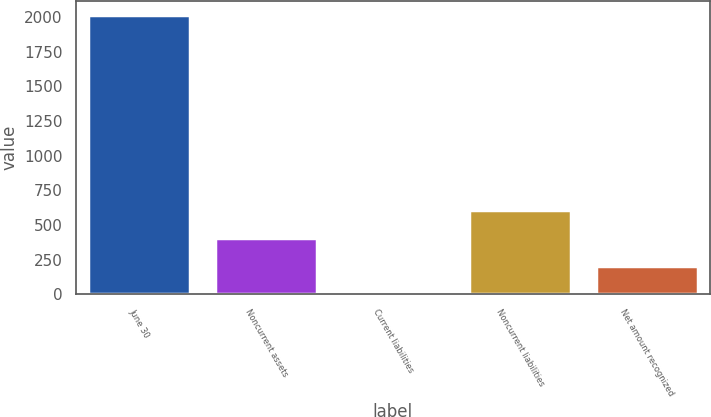<chart> <loc_0><loc_0><loc_500><loc_500><bar_chart><fcel>June 30<fcel>Noncurrent assets<fcel>Current liabilities<fcel>Noncurrent liabilities<fcel>Net amount recognized<nl><fcel>2019<fcel>408.52<fcel>5.9<fcel>609.83<fcel>207.21<nl></chart> 